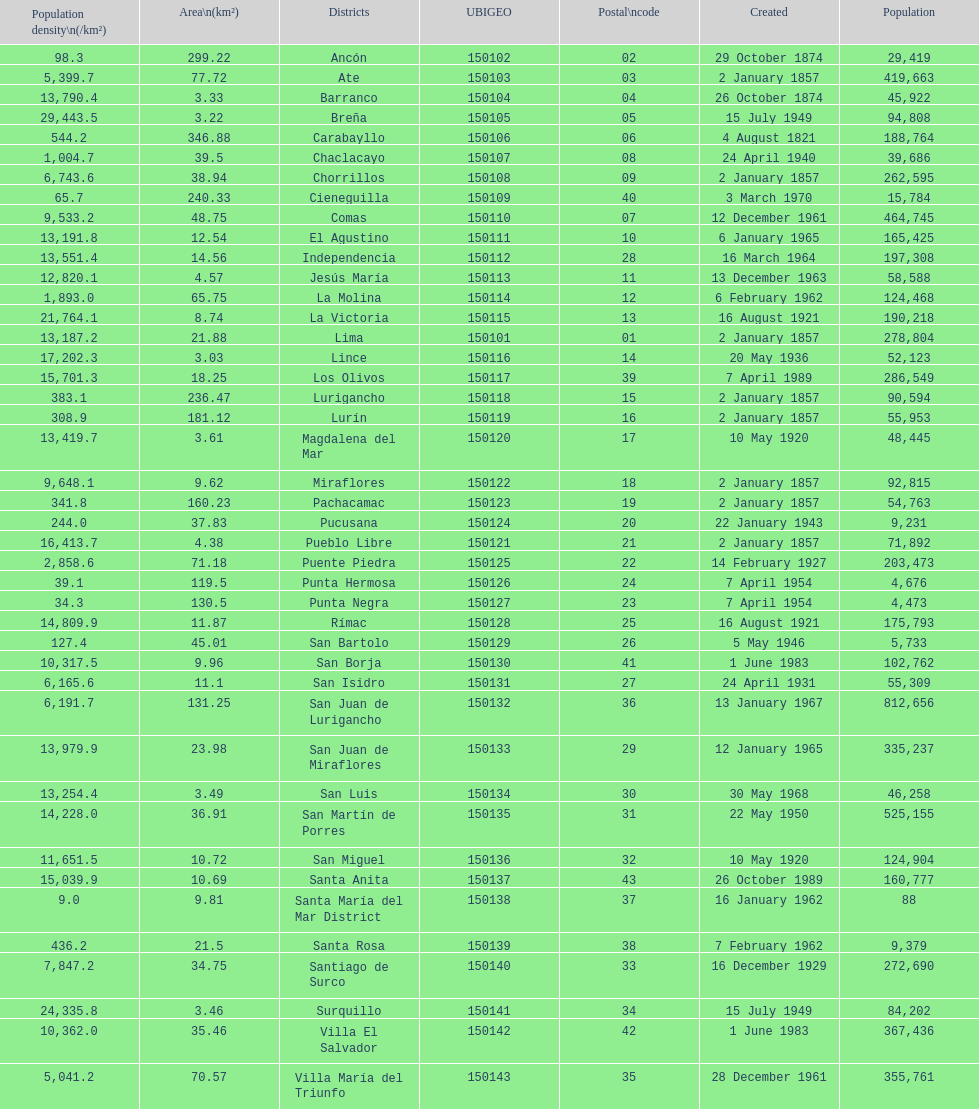What is the total number of districts of lima? 43. 